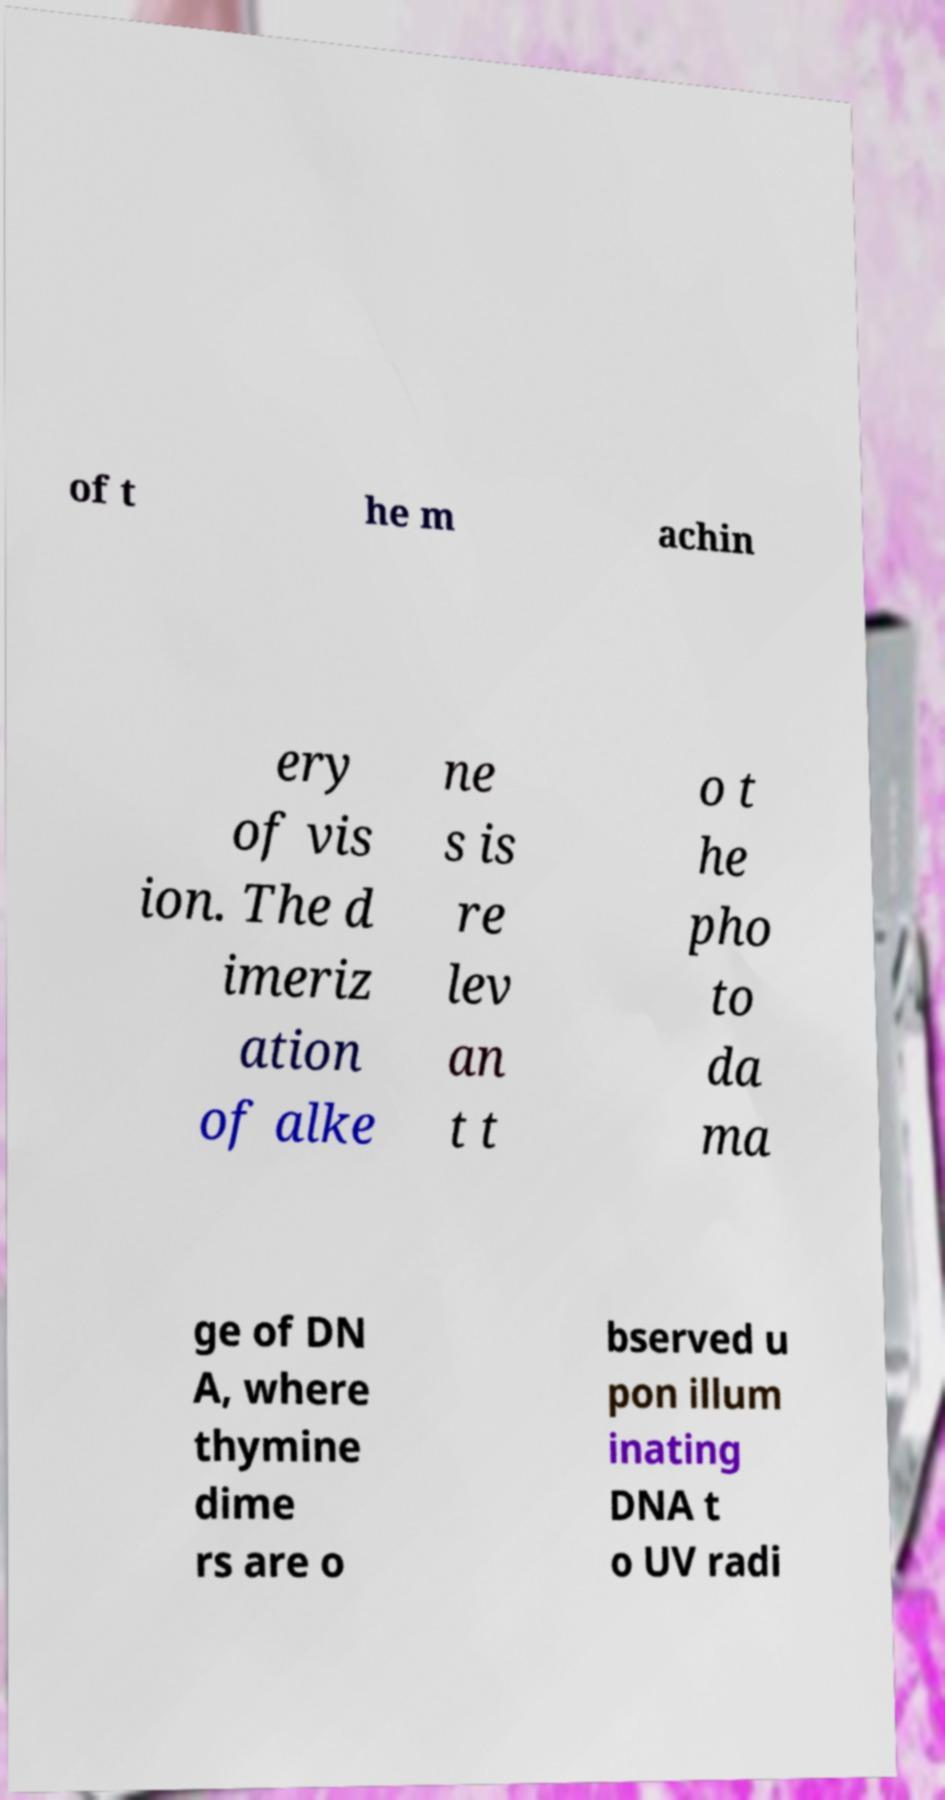Can you accurately transcribe the text from the provided image for me? of t he m achin ery of vis ion. The d imeriz ation of alke ne s is re lev an t t o t he pho to da ma ge of DN A, where thymine dime rs are o bserved u pon illum inating DNA t o UV radi 